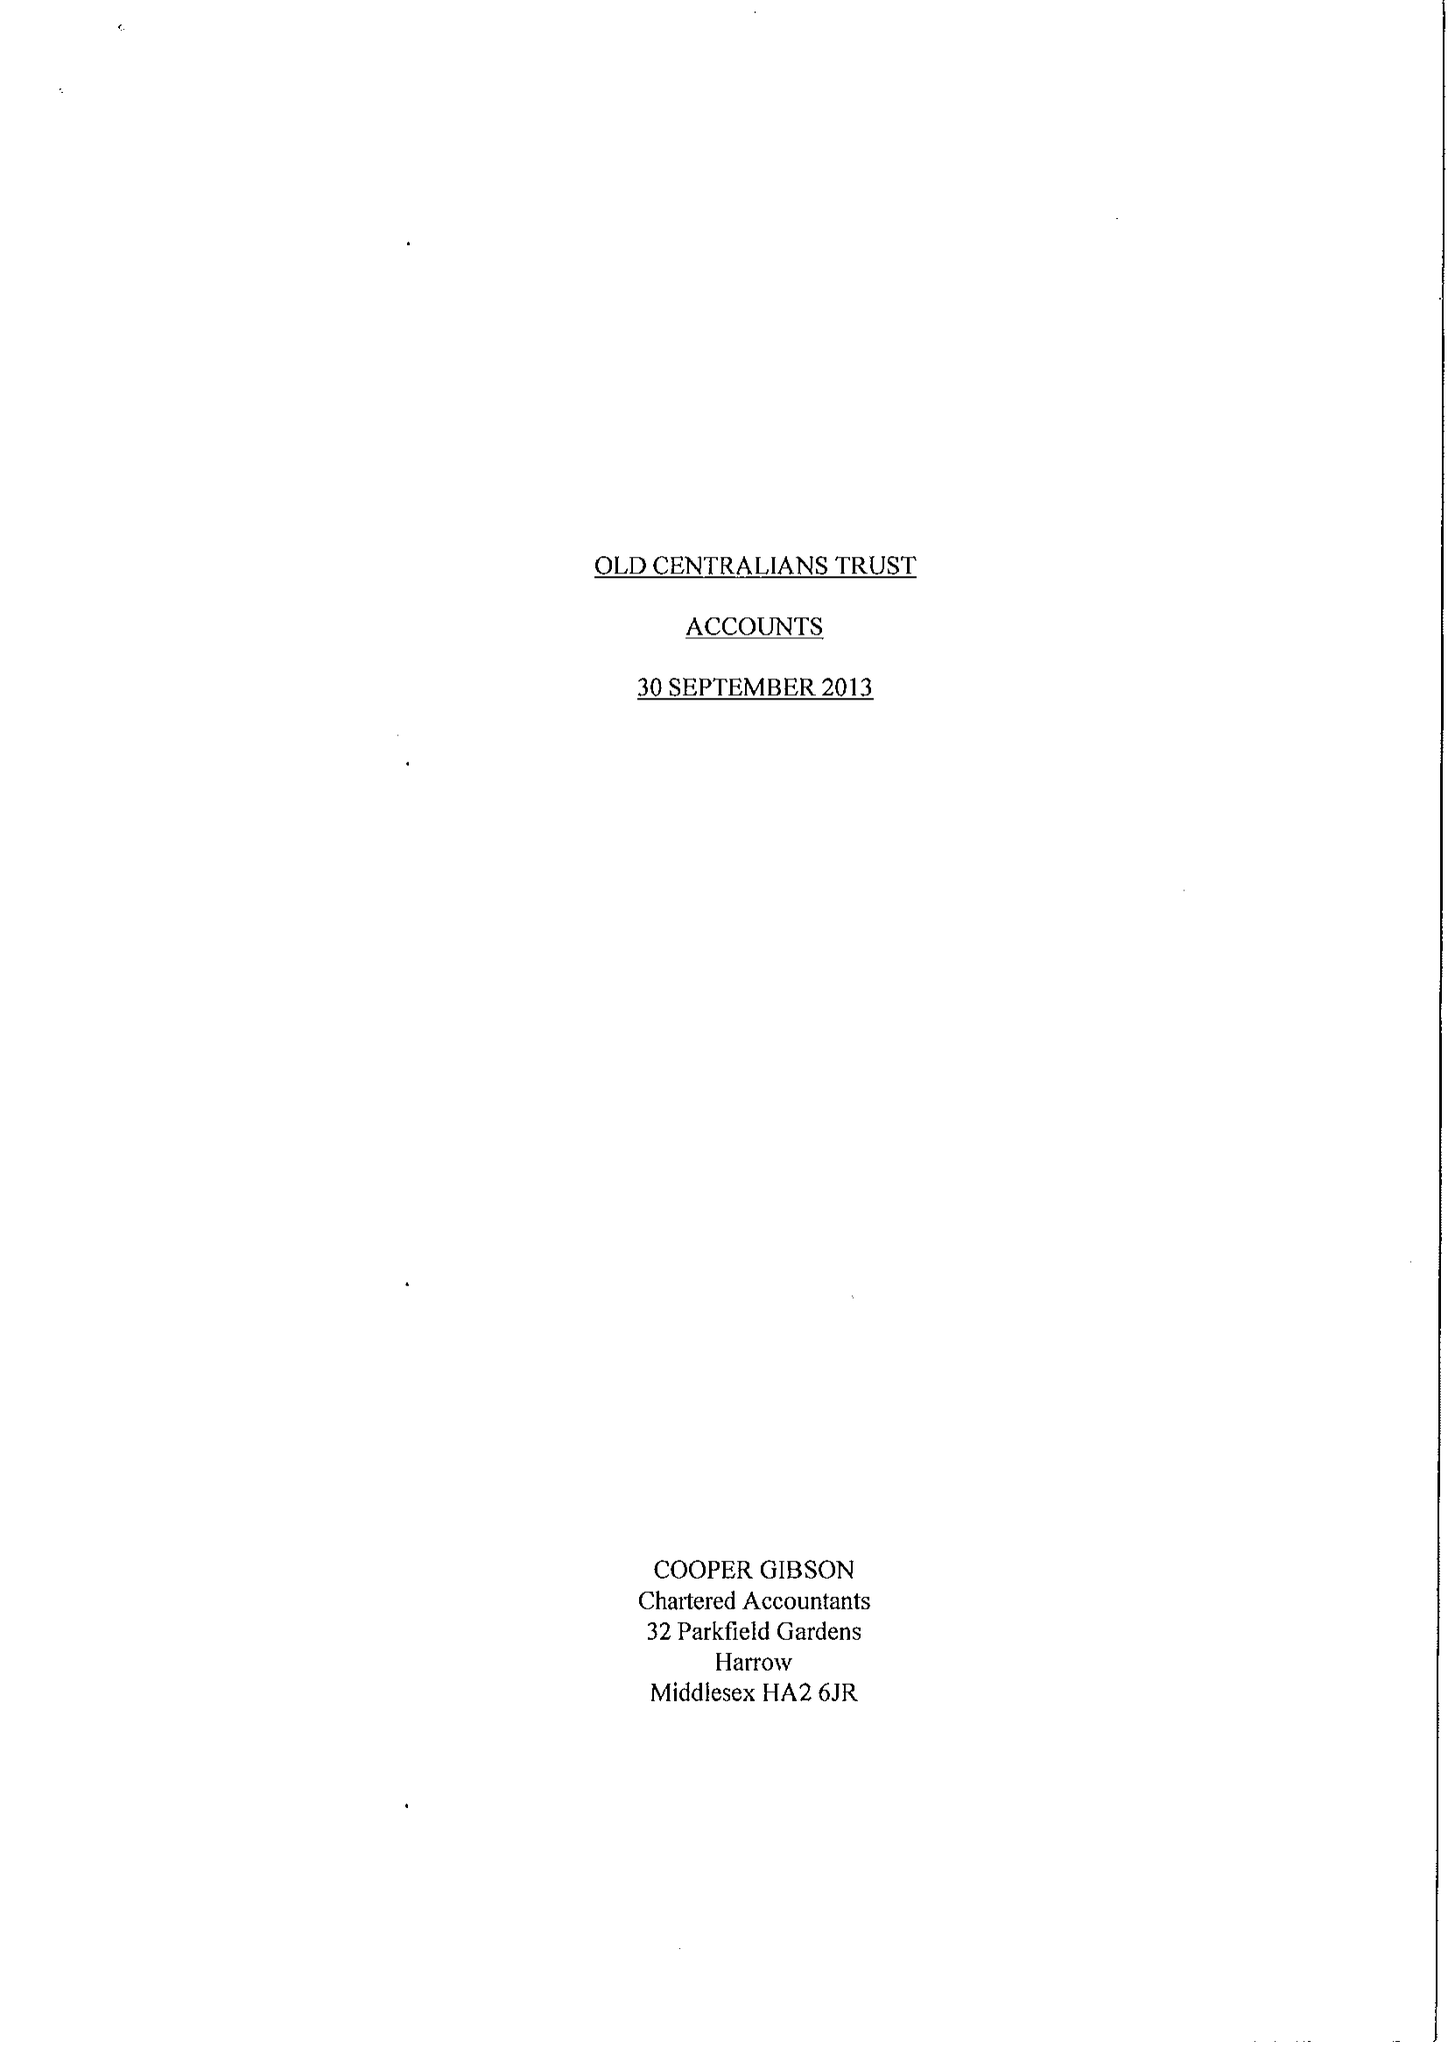What is the value for the charity_number?
Answer the question using a single word or phrase. 1048552 